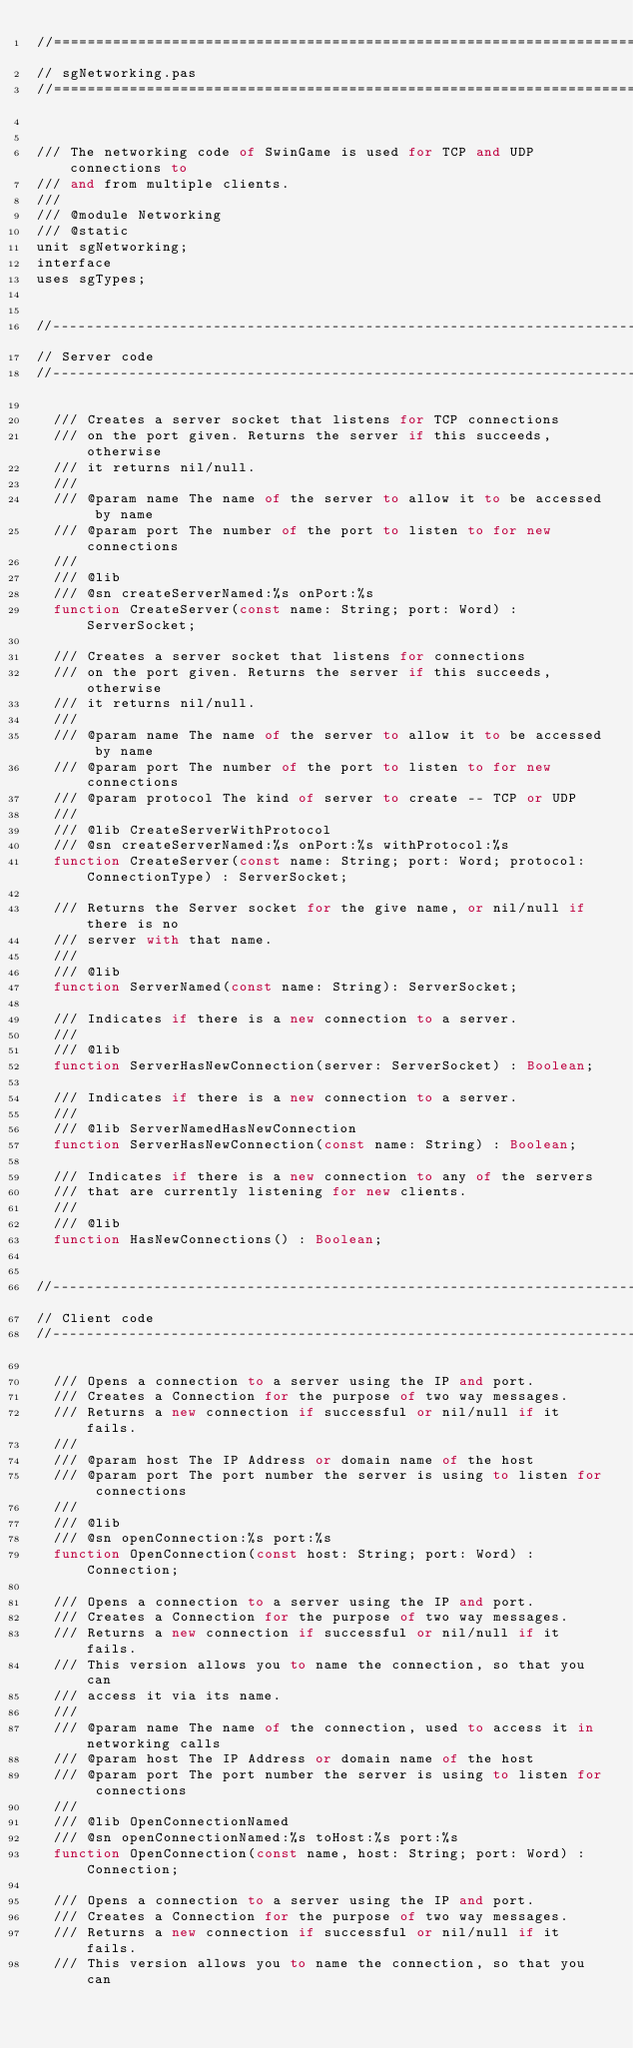Convert code to text. <code><loc_0><loc_0><loc_500><loc_500><_Pascal_>//=============================================================================
// sgNetworking.pas
//=============================================================================


/// The networking code of SwinGame is used for TCP and UDP connections to
/// and from multiple clients.
///
/// @module Networking
/// @static
unit sgNetworking;
interface
uses sgTypes;


//----------------------------------------------------------------------------
// Server code
//----------------------------------------------------------------------------

  /// Creates a server socket that listens for TCP connections
  /// on the port given. Returns the server if this succeeds, otherwise
  /// it returns nil/null.
  ///
  /// @param name The name of the server to allow it to be accessed by name
  /// @param port The number of the port to listen to for new connections
  ///
  /// @lib
  /// @sn createServerNamed:%s onPort:%s
  function CreateServer(const name: String; port: Word) : ServerSocket;

  /// Creates a server socket that listens for connections
  /// on the port given. Returns the server if this succeeds, otherwise
  /// it returns nil/null.
  ///
  /// @param name The name of the server to allow it to be accessed by name
  /// @param port The number of the port to listen to for new connections
  /// @param protocol The kind of server to create -- TCP or UDP
  ///
  /// @lib CreateServerWithProtocol
  /// @sn createServerNamed:%s onPort:%s withProtocol:%s
  function CreateServer(const name: String; port: Word; protocol: ConnectionType) : ServerSocket;

  /// Returns the Server socket for the give name, or nil/null if there is no
  /// server with that name.
  ///
  /// @lib
  function ServerNamed(const name: String): ServerSocket;

  /// Indicates if there is a new connection to a server.
  ///
  /// @lib
  function ServerHasNewConnection(server: ServerSocket) : Boolean;

  /// Indicates if there is a new connection to a server.
  ///
  /// @lib ServerNamedHasNewConnection
  function ServerHasNewConnection(const name: String) : Boolean;

  /// Indicates if there is a new connection to any of the servers
  /// that are currently listening for new clients.
  ///
  /// @lib
  function HasNewConnections() : Boolean;


//----------------------------------------------------------------------------
// Client code
//----------------------------------------------------------------------------

  /// Opens a connection to a server using the IP and port.
  /// Creates a Connection for the purpose of two way messages.
  /// Returns a new connection if successful or nil/null if it fails.
  ///
  /// @param host The IP Address or domain name of the host
  /// @param port The port number the server is using to listen for connections
  ///
  /// @lib
  /// @sn openConnection:%s port:%s
  function OpenConnection(const host: String; port: Word) : Connection;

  /// Opens a connection to a server using the IP and port.
  /// Creates a Connection for the purpose of two way messages.
  /// Returns a new connection if successful or nil/null if it fails.
  /// This version allows you to name the connection, so that you can
  /// access it via its name.
  ///
  /// @param name The name of the connection, used to access it in networking calls
  /// @param host The IP Address or domain name of the host
  /// @param port The port number the server is using to listen for connections
  ///
  /// @lib OpenConnectionNamed
  /// @sn openConnectionNamed:%s toHost:%s port:%s
  function OpenConnection(const name, host: String; port: Word) : Connection;

  /// Opens a connection to a server using the IP and port.
  /// Creates a Connection for the purpose of two way messages.
  /// Returns a new connection if successful or nil/null if it fails.
  /// This version allows you to name the connection, so that you can</code> 